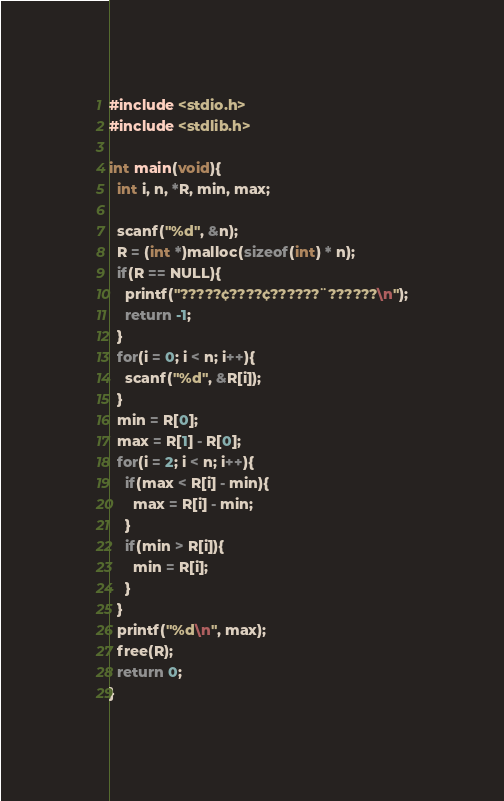Convert code to text. <code><loc_0><loc_0><loc_500><loc_500><_C_>#include <stdio.h>
#include <stdlib.h>

int main(void){
  int i, n, *R, min, max;

  scanf("%d", &n);
  R = (int *)malloc(sizeof(int) * n);
  if(R == NULL){
    printf("?????¢????¢??????¨??????\n");
    return -1;
  }
  for(i = 0; i < n; i++){
    scanf("%d", &R[i]);
  }
  min = R[0];
  max = R[1] - R[0];
  for(i = 2; i < n; i++){
    if(max < R[i] - min){
      max = R[i] - min;
    }
    if(min > R[i]){
      min = R[i];
    }
  }
  printf("%d\n", max);
  free(R);
  return 0;
}</code> 